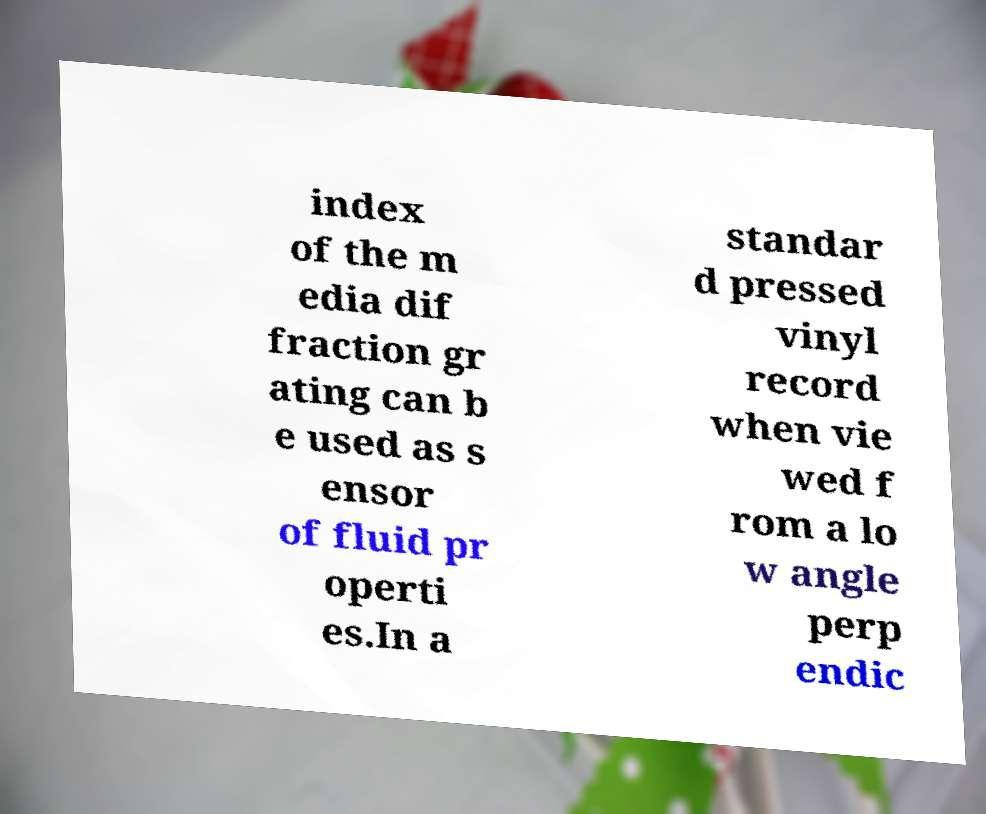I need the written content from this picture converted into text. Can you do that? index of the m edia dif fraction gr ating can b e used as s ensor of fluid pr operti es.In a standar d pressed vinyl record when vie wed f rom a lo w angle perp endic 